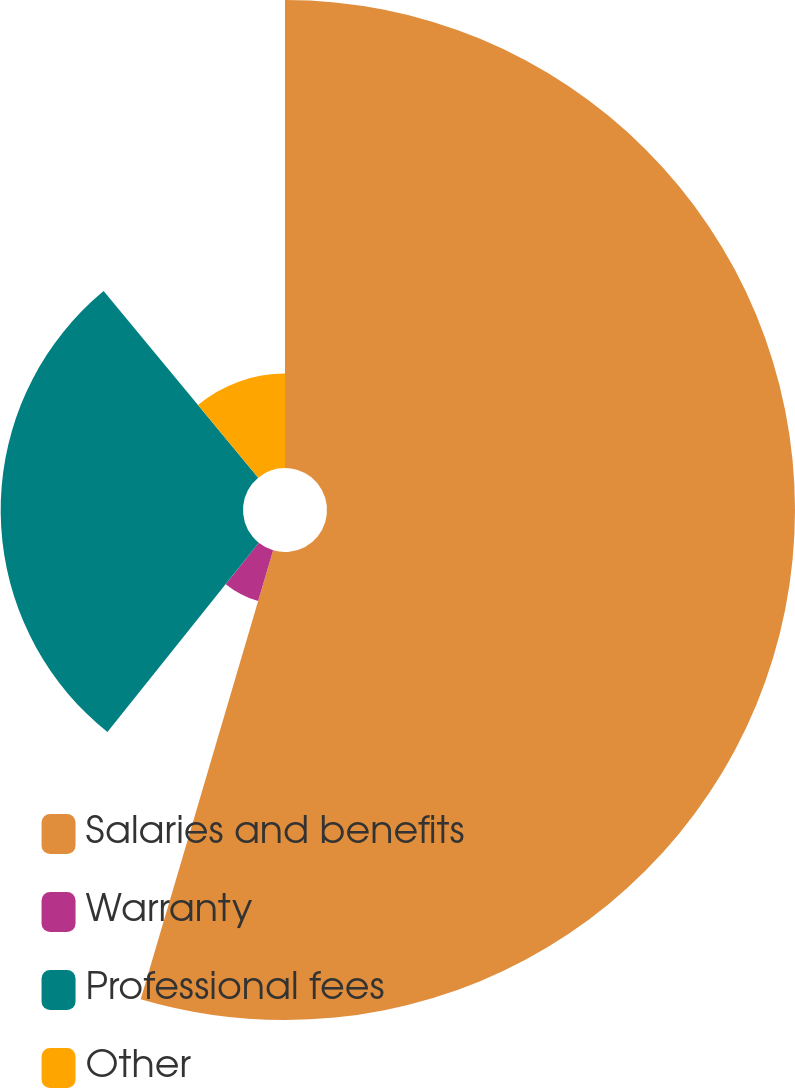Convert chart. <chart><loc_0><loc_0><loc_500><loc_500><pie_chart><fcel>Salaries and benefits<fcel>Warranty<fcel>Professional fees<fcel>Other<nl><fcel>54.56%<fcel>6.17%<fcel>28.25%<fcel>11.01%<nl></chart> 